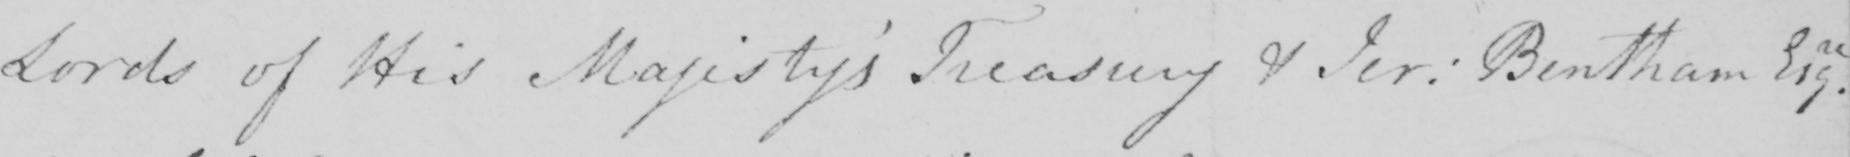Transcribe the text shown in this historical manuscript line. Lords of His Majesty ' s Treasury & Jer :  Bentham Esqre . 